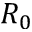<formula> <loc_0><loc_0><loc_500><loc_500>R _ { 0 }</formula> 